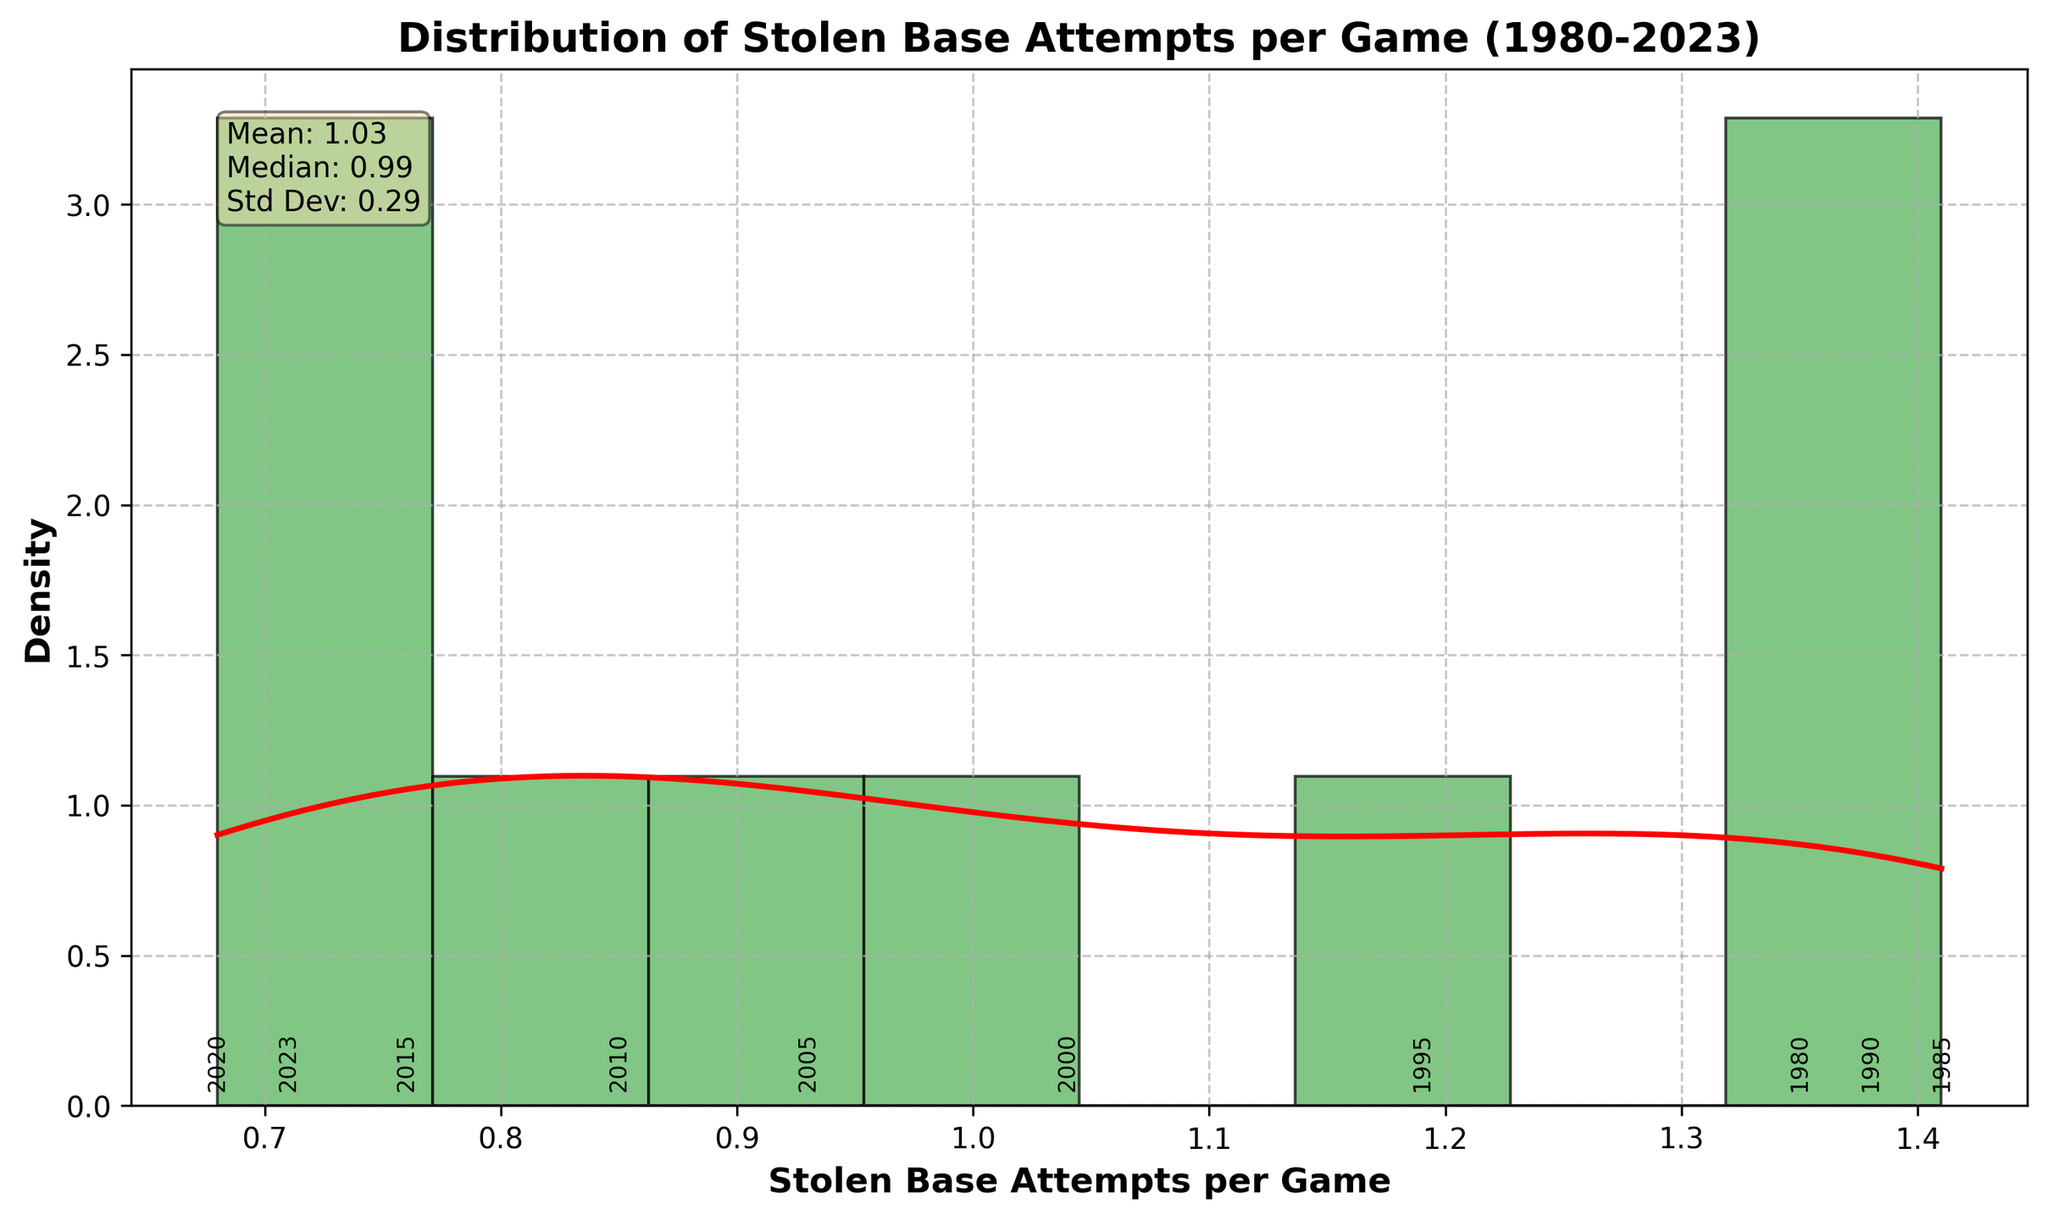What is the title of the figure? The title is located at the top of the figure and provides a summary of the data being presented. It reads: "Distribution of Stolen Base Attempts per Game (1980-2023)".
Answer: Distribution of Stolen Base Attempts per Game (1980-2023) How many bins are used in the histogram? The number of bins in a histogram is indicated by the distinct vertical bars present in the plot. There are 8 bins visible in the histogram.
Answer: 8 What year has the highest stolen base attempts per game? By observing the annotated data points on the x-axis of the histogram, we can see that the year 1985 has the highest value, which is 1.41.
Answer: 1985 What's the mean value of stolen base attempts per game? The mean value is provided in the text box within the figure, under the label "Mean". The mean value is 1.03.
Answer: 1.03 Which year has the lowest stolen base attempts per game? The annotated data points along the x-axis help us identify the lowest value, which corresponds to the year 2020, having a value of 0.68.
Answer: 2020 What is the color used for the KDE (density curve)? The KDE curve is highlighted distinctly in red, making it easy to differentiate from the histogram bars.
Answer: Red Is the median value of stolen base attempts per game higher than the mean? The text box in the figure provides both the median and the mean values. By comparing these values, with the median being 0.89 and the mean being 1.03, it is clear that the median is not higher than the mean.
Answer: No How does the number of stolen base attempts per game change over time? By observing the annotated years and their respective values on the x-axis, there is a clear downward trend from 1980 to 2023, indicating a decrease in the number of stolen base attempts per game over time.
Answer: Decrease What value of stolen base attempts per game is most frequently occurring, as observed from the histogram? The histogram's tallest bar indicates the most frequently occurring range of stolen base attempts per game. The peak appears around the 0.75-0.85 range.
Answer: 0.75-0.85 Does the KDE curve have a single peak, or is it multimodal? Observing the red KDE curve, we can see that it has a single prominent peak, indicating a unimodal distribution of stolen base attempts per game.
Answer: Single peak 